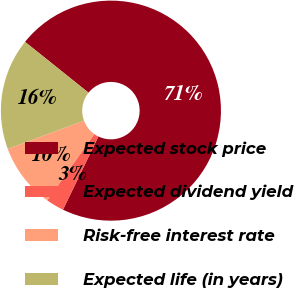<chart> <loc_0><loc_0><loc_500><loc_500><pie_chart><fcel>Expected stock price<fcel>Expected dividend yield<fcel>Risk-free interest rate<fcel>Expected life (in years)<nl><fcel>71.43%<fcel>2.65%<fcel>9.52%<fcel>16.4%<nl></chart> 